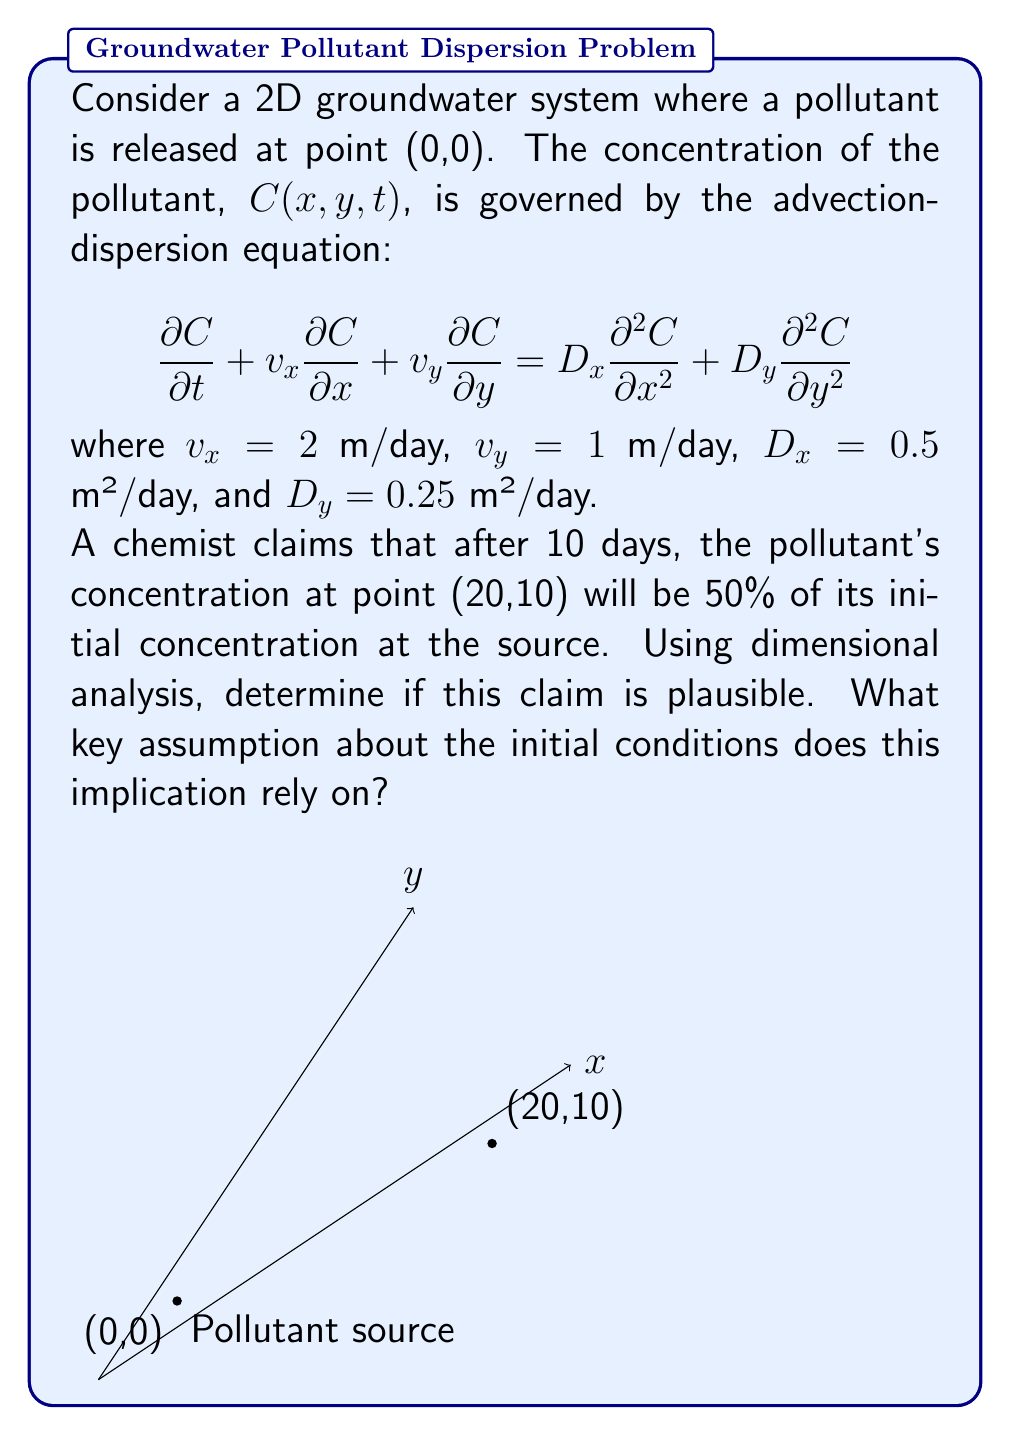Show me your answer to this math problem. Let's approach this step-by-step using dimensional analysis:

1) First, we need to identify the relevant dimensionless parameters. In advection-dispersion problems, these are typically the Peclet numbers:

   $Pe_x = \frac{v_x L}{D_x}$ and $Pe_y = \frac{v_y L}{D_y}$

   where L is a characteristic length scale.

2) We can use the distance to the point of interest as our length scale:
   $L = \sqrt{20^2 + 10^2} = \sqrt{500} \approx 22.36$ m

3) Calculate the Peclet numbers:
   $Pe_x = \frac{2 \cdot 22.36}{0.5} \approx 89.44$
   $Pe_y = \frac{1 \cdot 22.36}{0.25} \approx 89.44$

4) The high Peclet numbers indicate that advection dominates over dispersion.

5) In an advection-dominated system, we can estimate the time it takes for the pollutant to reach the point (20,10):

   $t \approx \frac{\sqrt{x^2 + y^2}}{\sqrt{v_x^2 + v_y^2}} = \frac{\sqrt{500}}{\sqrt{5}} \approx 10$ days

6) This coincides with the time given in the problem, suggesting that the pollutant would indeed reach the point (20,10) after about 10 days.

7) However, the claim that the concentration would be 50% of the initial concentration is not plausible. In a real system, dispersion and dilution would significantly reduce the concentration over this distance and time.

8) The implication of 50% concentration relies on the assumption of an instantaneous point source release with no dispersion, which is not realistic in groundwater systems.
Answer: Not plausible; assumes instantaneous point source with no dispersion. 